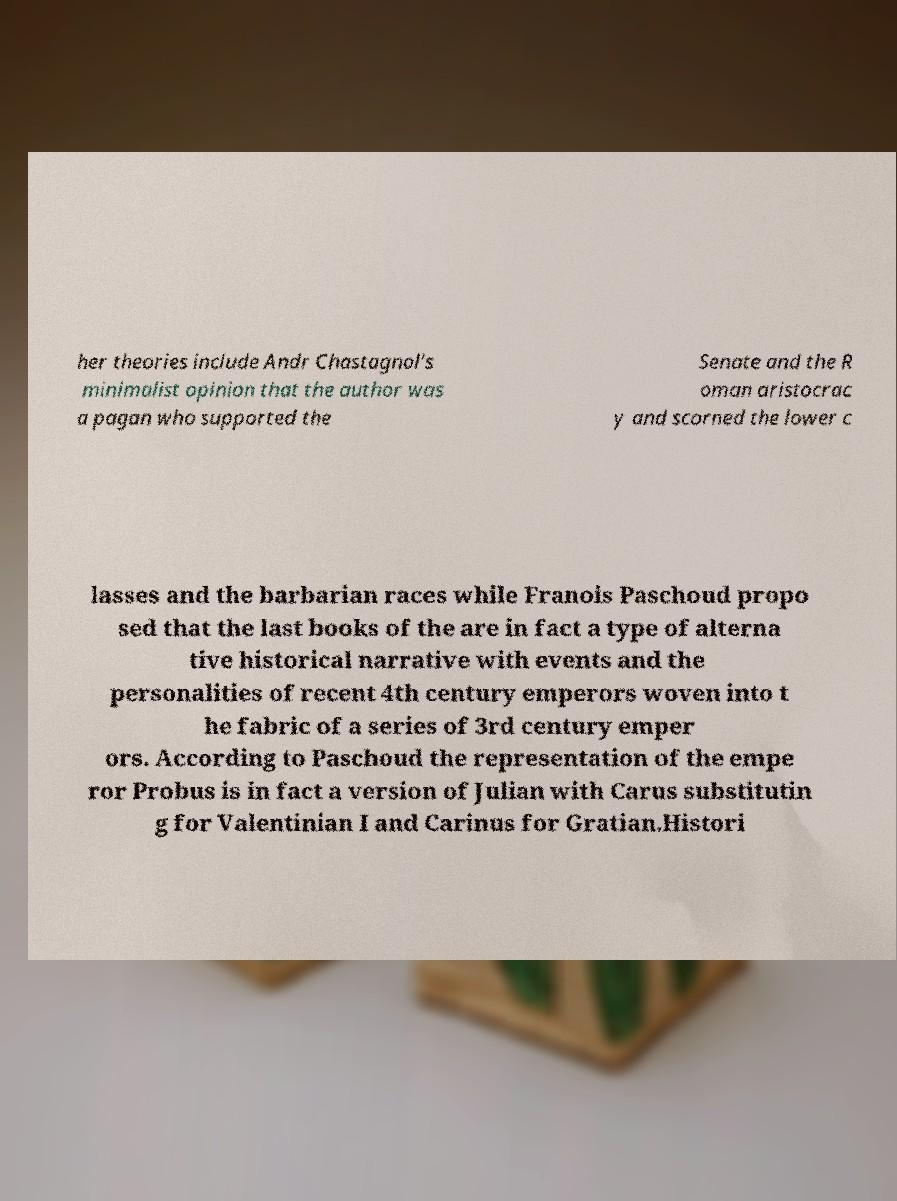Can you read and provide the text displayed in the image?This photo seems to have some interesting text. Can you extract and type it out for me? her theories include Andr Chastagnol's minimalist opinion that the author was a pagan who supported the Senate and the R oman aristocrac y and scorned the lower c lasses and the barbarian races while Franois Paschoud propo sed that the last books of the are in fact a type of alterna tive historical narrative with events and the personalities of recent 4th century emperors woven into t he fabric of a series of 3rd century emper ors. According to Paschoud the representation of the empe ror Probus is in fact a version of Julian with Carus substitutin g for Valentinian I and Carinus for Gratian.Histori 